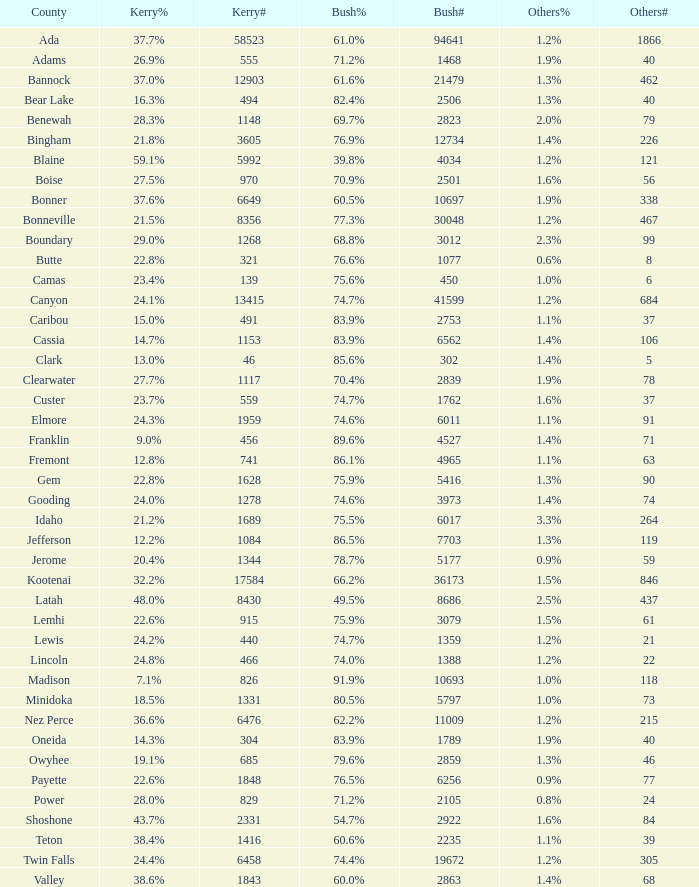What percentage of the votes in Oneida did Kerry win? 14.3%. 